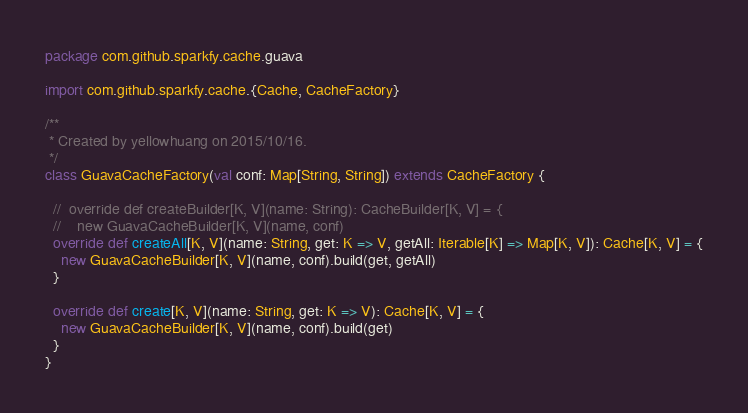Convert code to text. <code><loc_0><loc_0><loc_500><loc_500><_Scala_>package com.github.sparkfy.cache.guava

import com.github.sparkfy.cache.{Cache, CacheFactory}

/**
 * Created by yellowhuang on 2015/10/16.
 */
class GuavaCacheFactory(val conf: Map[String, String]) extends CacheFactory {

  //  override def createBuilder[K, V](name: String): CacheBuilder[K, V] = {
  //    new GuavaCacheBuilder[K, V](name, conf)
  override def createAll[K, V](name: String, get: K => V, getAll: Iterable[K] => Map[K, V]): Cache[K, V] = {
    new GuavaCacheBuilder[K, V](name, conf).build(get, getAll)
  }

  override def create[K, V](name: String, get: K => V): Cache[K, V] = {
    new GuavaCacheBuilder[K, V](name, conf).build(get)
  }
}
</code> 